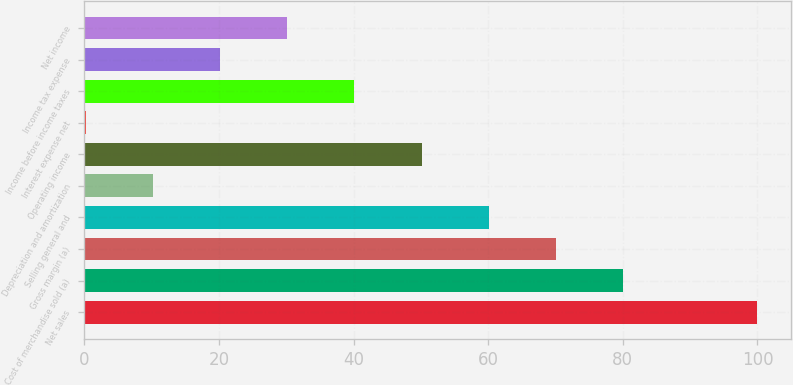<chart> <loc_0><loc_0><loc_500><loc_500><bar_chart><fcel>Net sales<fcel>Cost of merchandise sold (a)<fcel>Gross margin (a)<fcel>Selling general and<fcel>Depreciation and amortization<fcel>Operating income<fcel>Interest expense net<fcel>Income before income taxes<fcel>Income tax expense<fcel>Net income<nl><fcel>100<fcel>80.03<fcel>70.05<fcel>60.07<fcel>10.17<fcel>50.09<fcel>0.19<fcel>40.11<fcel>20.15<fcel>30.13<nl></chart> 